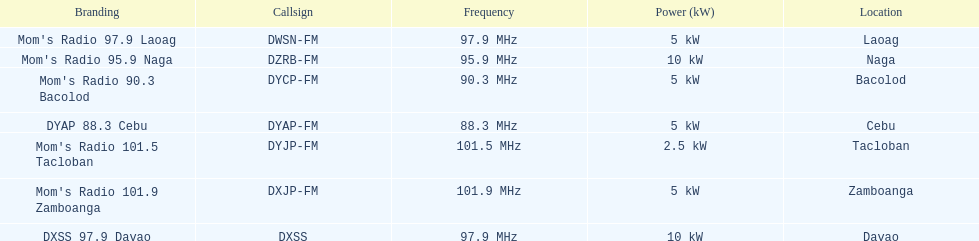What is the ultimate location displayed on this chart? Davao. 